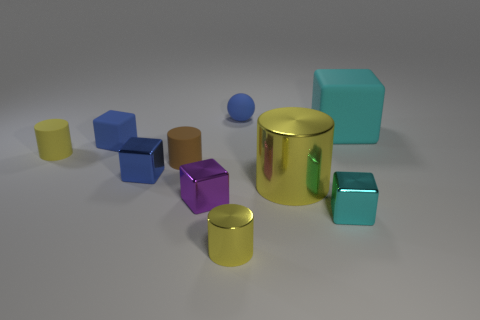Does the tiny matte thing that is behind the big cyan matte thing have the same color as the small block that is behind the yellow matte cylinder?
Your answer should be compact. Yes. There is a tiny matte object that is the same color as the small ball; what is its shape?
Make the answer very short. Cube. What number of metallic objects are yellow objects or large gray spheres?
Provide a short and direct response. 2. What color is the metal cylinder behind the small yellow cylinder on the right side of the yellow cylinder that is behind the large shiny cylinder?
Provide a short and direct response. Yellow. What color is the large shiny object that is the same shape as the small yellow matte thing?
Ensure brevity in your answer.  Yellow. Are there any other things that have the same color as the small rubber ball?
Give a very brief answer. Yes. What number of other things are there of the same material as the tiny brown cylinder
Your answer should be very brief. 4. The ball is what size?
Make the answer very short. Small. Are there any tiny blue things that have the same shape as the tiny yellow rubber object?
Offer a very short reply. No. What number of objects are large yellow cubes or blocks behind the tiny cyan block?
Give a very brief answer. 4. 